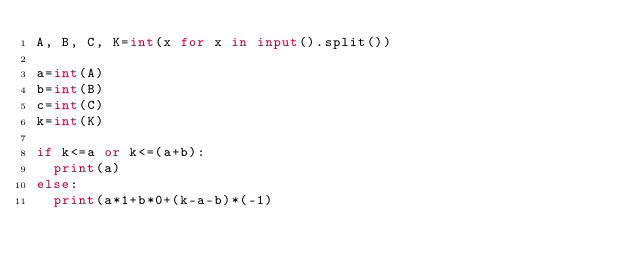<code> <loc_0><loc_0><loc_500><loc_500><_Python_>A, B, C, K=int(x for x in input().split())

a=int(A)
b=int(B)
c=int(C)
k=int(K)

if k<=a or k<=(a+b):
  print(a)
else:
  print(a*1+b*0+(k-a-b)*(-1)</code> 